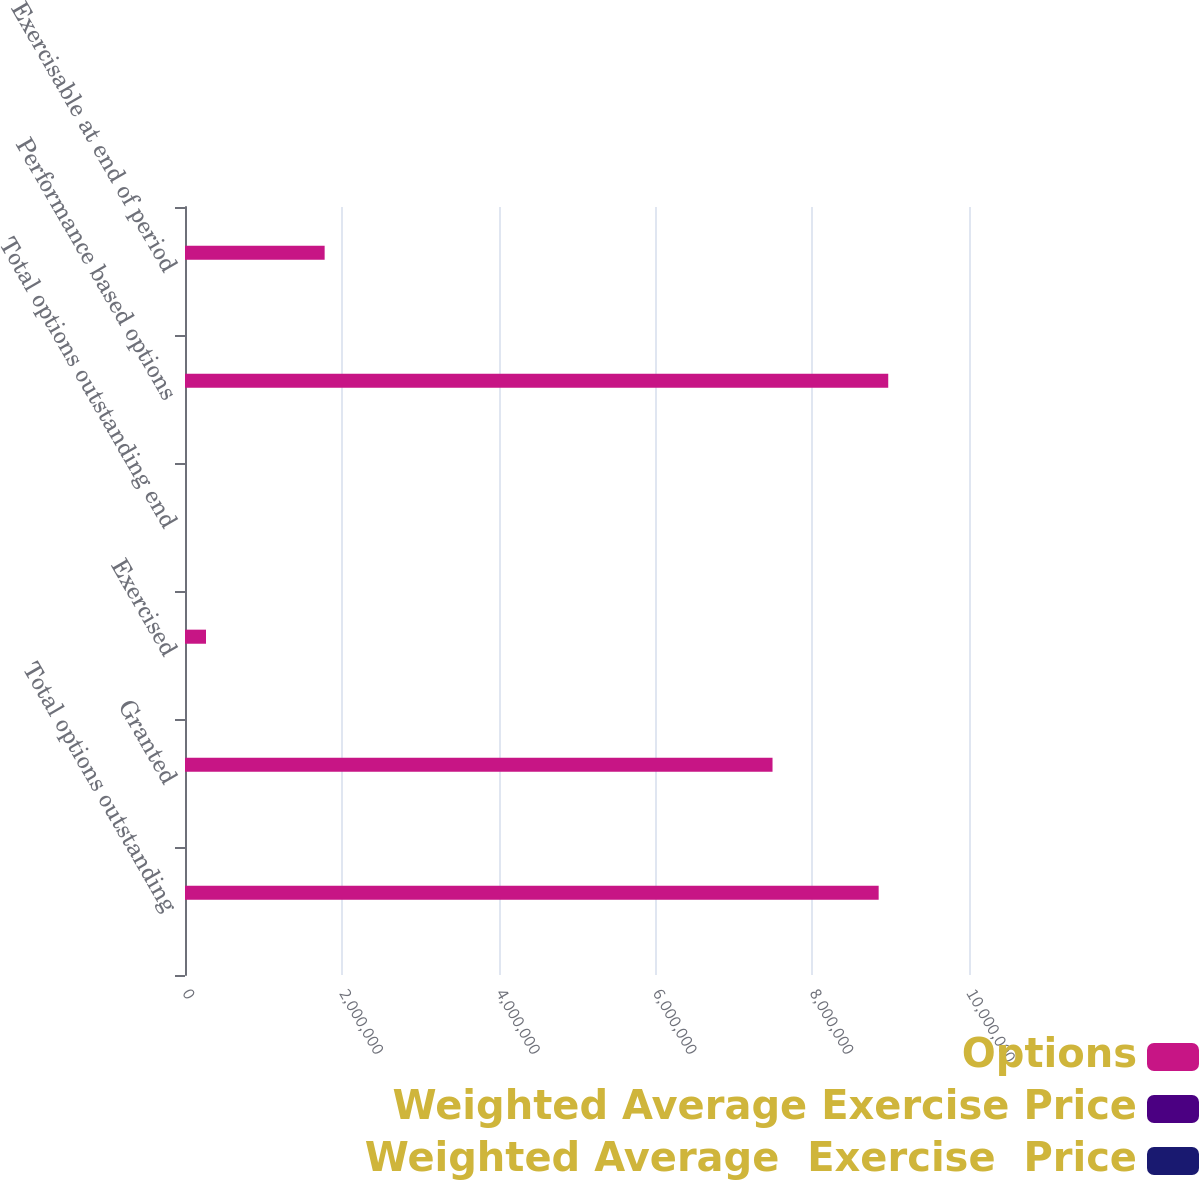Convert chart. <chart><loc_0><loc_0><loc_500><loc_500><stacked_bar_chart><ecel><fcel>Total options outstanding<fcel>Granted<fcel>Exercised<fcel>Total options outstanding end<fcel>Performance based options<fcel>Exercisable at end of period<nl><fcel>Options<fcel>8.84773e+06<fcel>7.49401e+06<fcel>267905<fcel>42.81<fcel>8.96989e+06<fcel>1.78115e+06<nl><fcel>Weighted Average Exercise Price<fcel>43.9<fcel>38.41<fcel>16.43<fcel>42.08<fcel>40.34<fcel>41.41<nl><fcel>Weighted Average  Exercise  Price<fcel>36.21<fcel>59.66<fcel>28.7<fcel>43.9<fcel>42.81<fcel>35.13<nl></chart> 